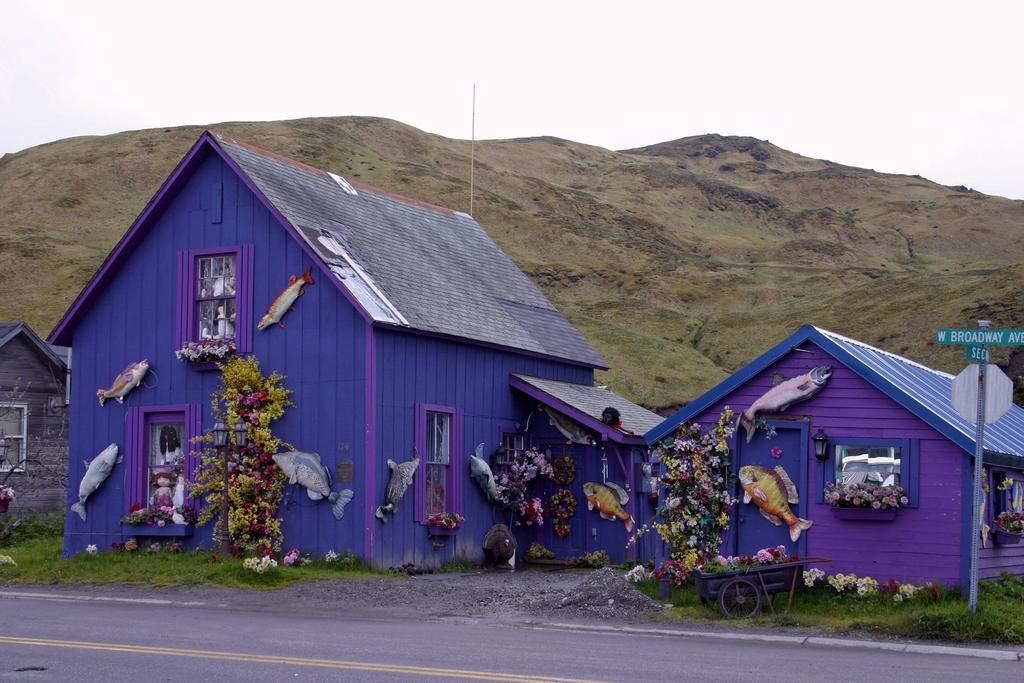What type of surface can be seen in the image? There is a road in the image. What type of vegetation is present in the image? There is grass, plants, and flowers in the image. What is attached to the house in the image? There are fishes attached to a house in the image. What structure is present in the image? There is a board on a pole in the image. What can be seen in the background of the image? There is a hill and the sky visible in the background of the image. Can you see a bat flying over the hill in the image? There is no bat present in the image. Is there a boat sailing on the grass in the image? There is no boat present in the image; the grass is not a body of water. Where is the giraffe located in the image? There is no giraffe present in the image. 